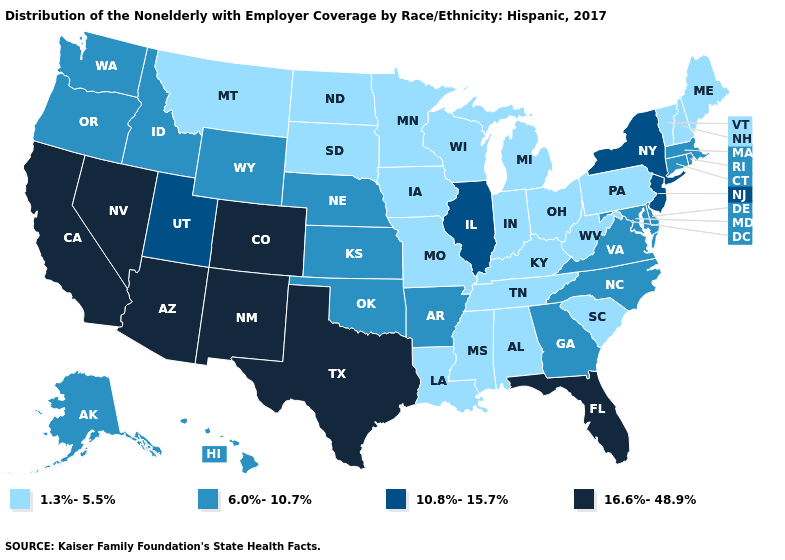What is the highest value in states that border New Hampshire?
Be succinct. 6.0%-10.7%. Which states have the lowest value in the South?
Quick response, please. Alabama, Kentucky, Louisiana, Mississippi, South Carolina, Tennessee, West Virginia. Does Massachusetts have the highest value in the Northeast?
Write a very short answer. No. What is the value of Idaho?
Answer briefly. 6.0%-10.7%. Which states have the lowest value in the South?
Quick response, please. Alabama, Kentucky, Louisiana, Mississippi, South Carolina, Tennessee, West Virginia. Does Connecticut have the lowest value in the Northeast?
Answer briefly. No. What is the highest value in the Northeast ?
Answer briefly. 10.8%-15.7%. What is the value of Maine?
Give a very brief answer. 1.3%-5.5%. Name the states that have a value in the range 10.8%-15.7%?
Answer briefly. Illinois, New Jersey, New York, Utah. What is the value of New Mexico?
Give a very brief answer. 16.6%-48.9%. How many symbols are there in the legend?
Answer briefly. 4. Name the states that have a value in the range 6.0%-10.7%?
Short answer required. Alaska, Arkansas, Connecticut, Delaware, Georgia, Hawaii, Idaho, Kansas, Maryland, Massachusetts, Nebraska, North Carolina, Oklahoma, Oregon, Rhode Island, Virginia, Washington, Wyoming. Among the states that border Delaware , does Maryland have the highest value?
Quick response, please. No. Name the states that have a value in the range 1.3%-5.5%?
Answer briefly. Alabama, Indiana, Iowa, Kentucky, Louisiana, Maine, Michigan, Minnesota, Mississippi, Missouri, Montana, New Hampshire, North Dakota, Ohio, Pennsylvania, South Carolina, South Dakota, Tennessee, Vermont, West Virginia, Wisconsin. Does Vermont have a lower value than Pennsylvania?
Answer briefly. No. 